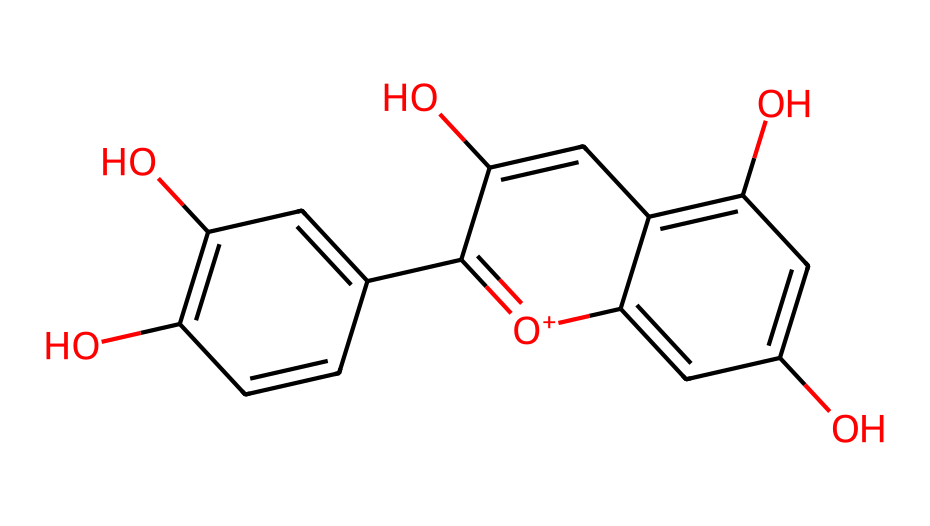What is the molecular formula of this anthocyanin? By analyzing the chemical structure represented by its SMILES notation, we count the number of carbon, hydrogen, and oxygen atoms. The structure shows 15 carbon atoms, 11 hydrogen atoms, and 6 oxygen atoms. Therefore, the molecular formula can be deduced as C15H11O6.
Answer: C15H11O6 How many hydroxyl groups are present in this structure? Examining the chemical structure, we can identify the hydroxyl (–OH) groups. There are three –OH groups highlighted in the structure, which are associated with the phenolic and aromatic components.
Answer: 3 What color range do anthocyanins typically produce? Anthocyanins are known to produce colors ranging from red to purple and blue, depending on their chemical structure and the pH of their environment. This property is characteristic of anthocyanins as a group.
Answer: red to purple and blue Is this compound soluble in water? Anthocyanins, being phenolic compounds with multiple hydroxyl groups, are generally soluble in water due to their ability to form hydrogen bonds with water molecules. This solubility is typical for anthocyanins.
Answer: Yes What functional groups can be identified in this anthocyanin? By analyzing the structure, we see the presence of hydroxyl (-OH) groups as well as a ketone (=O) group, both of which contribute to the compound's properties. The presence of these functional groups indicates the polarity and potential reactivity of the molecule.
Answer: hydroxyl and ketone Why does this anthocyanin impart color to fruits and vegetables? The color imparted by anthocyanins comes from the delocalized electrons in their conjugated ring structure, which interact with light. Their ability to absorb specific wavelengths of light leads to the various colors seen in fruits and vegetables.
Answer: delocalized electrons 